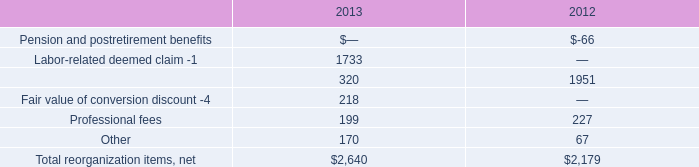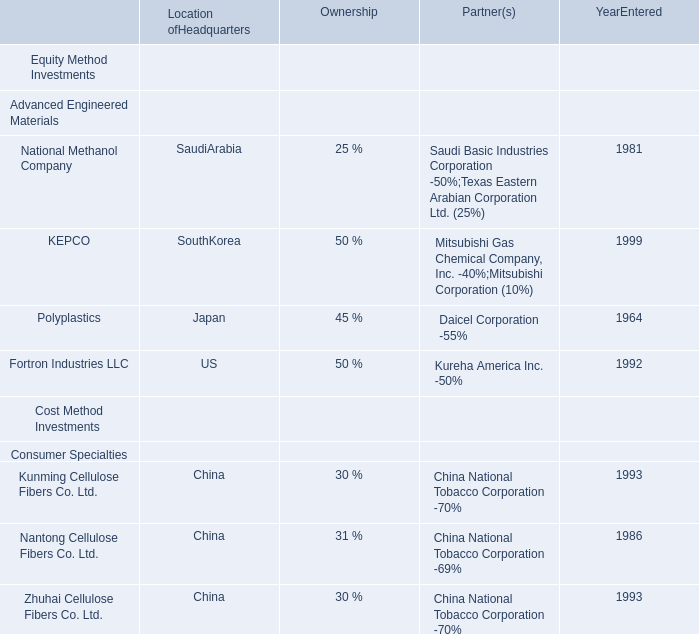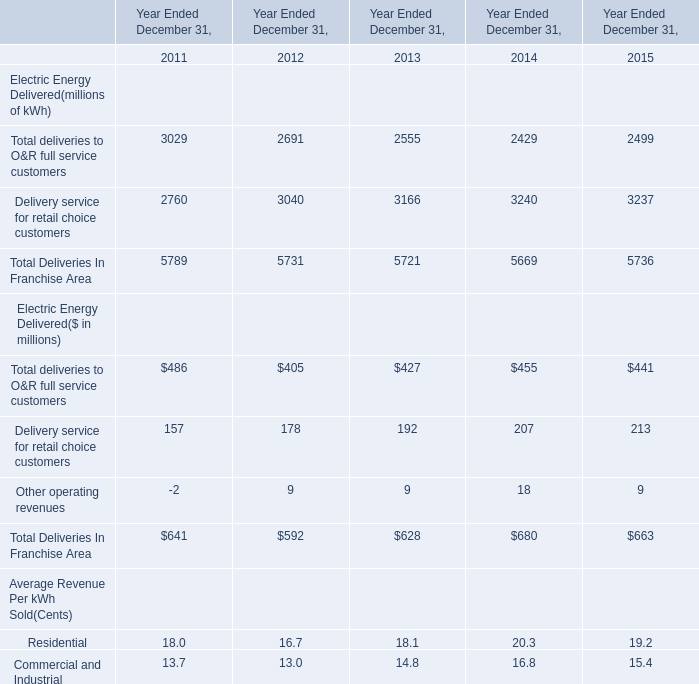by how much did total reorganization items net increase from 2012 to 2013? 
Computations: ((2640 - 2179) / 2179)
Answer: 0.21156. 